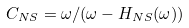Convert formula to latex. <formula><loc_0><loc_0><loc_500><loc_500>C _ { N S } = \omega / ( \omega - H _ { N S } ( \omega ) )</formula> 